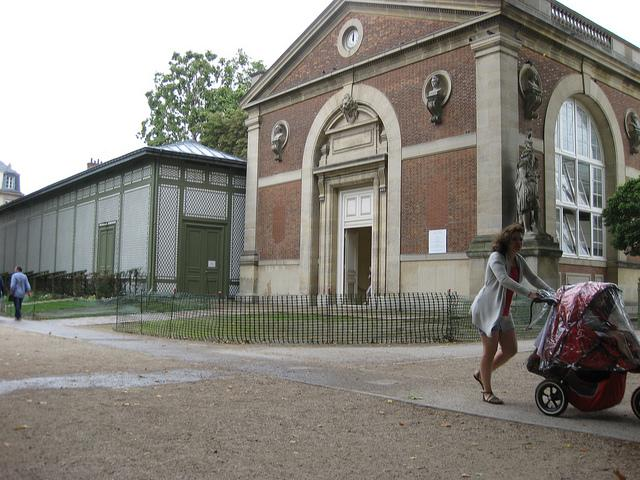What is the woman pushing?

Choices:
A) sled
B) stroller
C) cart
D) wagon stroller 